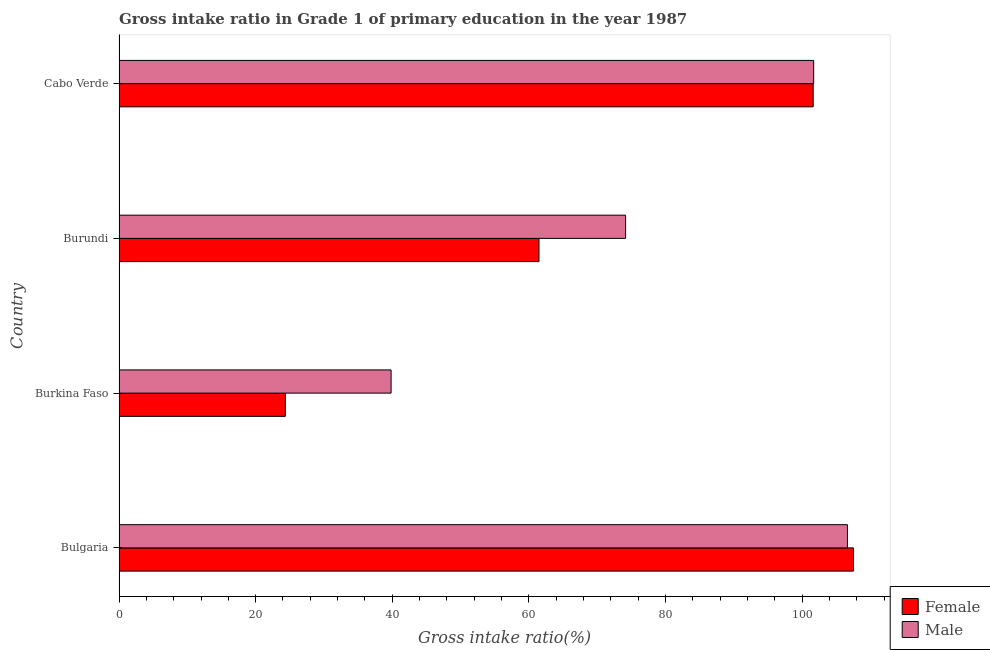How many groups of bars are there?
Your answer should be compact. 4. Are the number of bars per tick equal to the number of legend labels?
Provide a succinct answer. Yes. How many bars are there on the 3rd tick from the top?
Ensure brevity in your answer.  2. What is the label of the 1st group of bars from the top?
Provide a succinct answer. Cabo Verde. In how many cases, is the number of bars for a given country not equal to the number of legend labels?
Make the answer very short. 0. What is the gross intake ratio(male) in Burundi?
Ensure brevity in your answer.  74.16. Across all countries, what is the maximum gross intake ratio(male)?
Offer a terse response. 106.64. Across all countries, what is the minimum gross intake ratio(female)?
Offer a very short reply. 24.35. In which country was the gross intake ratio(male) minimum?
Make the answer very short. Burkina Faso. What is the total gross intake ratio(male) in the graph?
Offer a very short reply. 322.32. What is the difference between the gross intake ratio(female) in Burkina Faso and that in Cabo Verde?
Offer a terse response. -77.28. What is the difference between the gross intake ratio(male) in Burundi and the gross intake ratio(female) in Bulgaria?
Ensure brevity in your answer.  -33.36. What is the average gross intake ratio(female) per country?
Your answer should be compact. 73.74. What is the difference between the gross intake ratio(male) and gross intake ratio(female) in Burkina Faso?
Give a very brief answer. 15.48. What is the ratio of the gross intake ratio(male) in Burundi to that in Cabo Verde?
Offer a very short reply. 0.73. Is the gross intake ratio(female) in Burkina Faso less than that in Burundi?
Provide a short and direct response. Yes. What is the difference between the highest and the second highest gross intake ratio(male)?
Keep it short and to the point. 4.94. What is the difference between the highest and the lowest gross intake ratio(male)?
Your response must be concise. 66.81. Is the sum of the gross intake ratio(female) in Bulgaria and Burkina Faso greater than the maximum gross intake ratio(male) across all countries?
Provide a short and direct response. Yes. What does the 1st bar from the top in Burundi represents?
Your response must be concise. Male. What does the 1st bar from the bottom in Bulgaria represents?
Provide a succinct answer. Female. How many countries are there in the graph?
Give a very brief answer. 4. What is the difference between two consecutive major ticks on the X-axis?
Your answer should be compact. 20. Does the graph contain any zero values?
Ensure brevity in your answer.  No. Where does the legend appear in the graph?
Offer a very short reply. Bottom right. How many legend labels are there?
Give a very brief answer. 2. How are the legend labels stacked?
Give a very brief answer. Vertical. What is the title of the graph?
Keep it short and to the point. Gross intake ratio in Grade 1 of primary education in the year 1987. Does "National Visitors" appear as one of the legend labels in the graph?
Your response must be concise. No. What is the label or title of the X-axis?
Your answer should be compact. Gross intake ratio(%). What is the label or title of the Y-axis?
Provide a succinct answer. Country. What is the Gross intake ratio(%) of Female in Bulgaria?
Ensure brevity in your answer.  107.52. What is the Gross intake ratio(%) of Male in Bulgaria?
Offer a terse response. 106.64. What is the Gross intake ratio(%) of Female in Burkina Faso?
Your answer should be compact. 24.35. What is the Gross intake ratio(%) of Male in Burkina Faso?
Make the answer very short. 39.83. What is the Gross intake ratio(%) in Female in Burundi?
Your answer should be very brief. 61.48. What is the Gross intake ratio(%) in Male in Burundi?
Offer a very short reply. 74.16. What is the Gross intake ratio(%) in Female in Cabo Verde?
Offer a very short reply. 101.62. What is the Gross intake ratio(%) of Male in Cabo Verde?
Keep it short and to the point. 101.69. Across all countries, what is the maximum Gross intake ratio(%) in Female?
Your answer should be very brief. 107.52. Across all countries, what is the maximum Gross intake ratio(%) in Male?
Ensure brevity in your answer.  106.64. Across all countries, what is the minimum Gross intake ratio(%) of Female?
Your answer should be compact. 24.35. Across all countries, what is the minimum Gross intake ratio(%) in Male?
Offer a terse response. 39.83. What is the total Gross intake ratio(%) in Female in the graph?
Give a very brief answer. 294.97. What is the total Gross intake ratio(%) of Male in the graph?
Offer a very short reply. 322.32. What is the difference between the Gross intake ratio(%) of Female in Bulgaria and that in Burkina Faso?
Give a very brief answer. 83.18. What is the difference between the Gross intake ratio(%) in Male in Bulgaria and that in Burkina Faso?
Your response must be concise. 66.81. What is the difference between the Gross intake ratio(%) of Female in Bulgaria and that in Burundi?
Provide a short and direct response. 46.04. What is the difference between the Gross intake ratio(%) of Male in Bulgaria and that in Burundi?
Ensure brevity in your answer.  32.48. What is the difference between the Gross intake ratio(%) in Female in Bulgaria and that in Cabo Verde?
Provide a succinct answer. 5.9. What is the difference between the Gross intake ratio(%) of Male in Bulgaria and that in Cabo Verde?
Ensure brevity in your answer.  4.94. What is the difference between the Gross intake ratio(%) in Female in Burkina Faso and that in Burundi?
Your response must be concise. -37.14. What is the difference between the Gross intake ratio(%) of Male in Burkina Faso and that in Burundi?
Make the answer very short. -34.33. What is the difference between the Gross intake ratio(%) in Female in Burkina Faso and that in Cabo Verde?
Provide a short and direct response. -77.28. What is the difference between the Gross intake ratio(%) of Male in Burkina Faso and that in Cabo Verde?
Offer a terse response. -61.87. What is the difference between the Gross intake ratio(%) in Female in Burundi and that in Cabo Verde?
Keep it short and to the point. -40.14. What is the difference between the Gross intake ratio(%) in Male in Burundi and that in Cabo Verde?
Keep it short and to the point. -27.53. What is the difference between the Gross intake ratio(%) of Female in Bulgaria and the Gross intake ratio(%) of Male in Burkina Faso?
Make the answer very short. 67.69. What is the difference between the Gross intake ratio(%) in Female in Bulgaria and the Gross intake ratio(%) in Male in Burundi?
Your answer should be compact. 33.36. What is the difference between the Gross intake ratio(%) in Female in Bulgaria and the Gross intake ratio(%) in Male in Cabo Verde?
Ensure brevity in your answer.  5.83. What is the difference between the Gross intake ratio(%) in Female in Burkina Faso and the Gross intake ratio(%) in Male in Burundi?
Offer a very short reply. -49.82. What is the difference between the Gross intake ratio(%) of Female in Burkina Faso and the Gross intake ratio(%) of Male in Cabo Verde?
Ensure brevity in your answer.  -77.35. What is the difference between the Gross intake ratio(%) in Female in Burundi and the Gross intake ratio(%) in Male in Cabo Verde?
Provide a short and direct response. -40.21. What is the average Gross intake ratio(%) of Female per country?
Your answer should be compact. 73.74. What is the average Gross intake ratio(%) of Male per country?
Your response must be concise. 80.58. What is the difference between the Gross intake ratio(%) of Female and Gross intake ratio(%) of Male in Bulgaria?
Your answer should be very brief. 0.88. What is the difference between the Gross intake ratio(%) of Female and Gross intake ratio(%) of Male in Burkina Faso?
Your answer should be compact. -15.48. What is the difference between the Gross intake ratio(%) of Female and Gross intake ratio(%) of Male in Burundi?
Your answer should be very brief. -12.68. What is the difference between the Gross intake ratio(%) in Female and Gross intake ratio(%) in Male in Cabo Verde?
Your response must be concise. -0.07. What is the ratio of the Gross intake ratio(%) of Female in Bulgaria to that in Burkina Faso?
Offer a terse response. 4.42. What is the ratio of the Gross intake ratio(%) of Male in Bulgaria to that in Burkina Faso?
Provide a short and direct response. 2.68. What is the ratio of the Gross intake ratio(%) in Female in Bulgaria to that in Burundi?
Your response must be concise. 1.75. What is the ratio of the Gross intake ratio(%) in Male in Bulgaria to that in Burundi?
Provide a short and direct response. 1.44. What is the ratio of the Gross intake ratio(%) in Female in Bulgaria to that in Cabo Verde?
Your answer should be compact. 1.06. What is the ratio of the Gross intake ratio(%) of Male in Bulgaria to that in Cabo Verde?
Keep it short and to the point. 1.05. What is the ratio of the Gross intake ratio(%) in Female in Burkina Faso to that in Burundi?
Your response must be concise. 0.4. What is the ratio of the Gross intake ratio(%) of Male in Burkina Faso to that in Burundi?
Your answer should be compact. 0.54. What is the ratio of the Gross intake ratio(%) of Female in Burkina Faso to that in Cabo Verde?
Provide a succinct answer. 0.24. What is the ratio of the Gross intake ratio(%) in Male in Burkina Faso to that in Cabo Verde?
Keep it short and to the point. 0.39. What is the ratio of the Gross intake ratio(%) of Female in Burundi to that in Cabo Verde?
Provide a succinct answer. 0.6. What is the ratio of the Gross intake ratio(%) in Male in Burundi to that in Cabo Verde?
Make the answer very short. 0.73. What is the difference between the highest and the second highest Gross intake ratio(%) of Female?
Ensure brevity in your answer.  5.9. What is the difference between the highest and the second highest Gross intake ratio(%) in Male?
Offer a very short reply. 4.94. What is the difference between the highest and the lowest Gross intake ratio(%) in Female?
Give a very brief answer. 83.18. What is the difference between the highest and the lowest Gross intake ratio(%) in Male?
Ensure brevity in your answer.  66.81. 